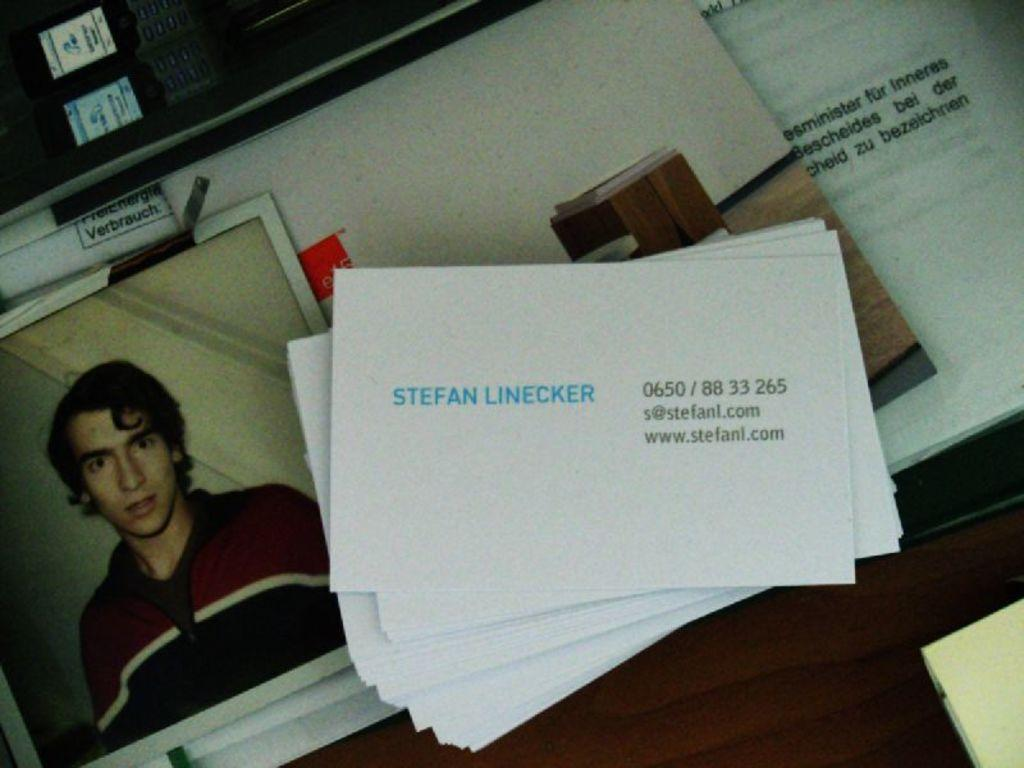Provide a one-sentence caption for the provided image. Stephan Linecker is in the photo and he is wearing a zip up sweater. 